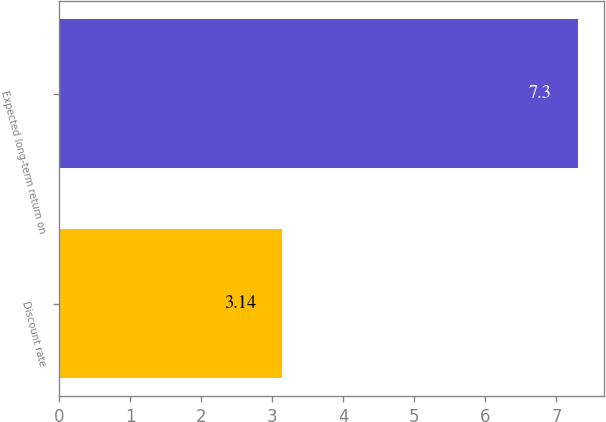Convert chart to OTSL. <chart><loc_0><loc_0><loc_500><loc_500><bar_chart><fcel>Discount rate<fcel>Expected long-term return on<nl><fcel>3.14<fcel>7.3<nl></chart> 